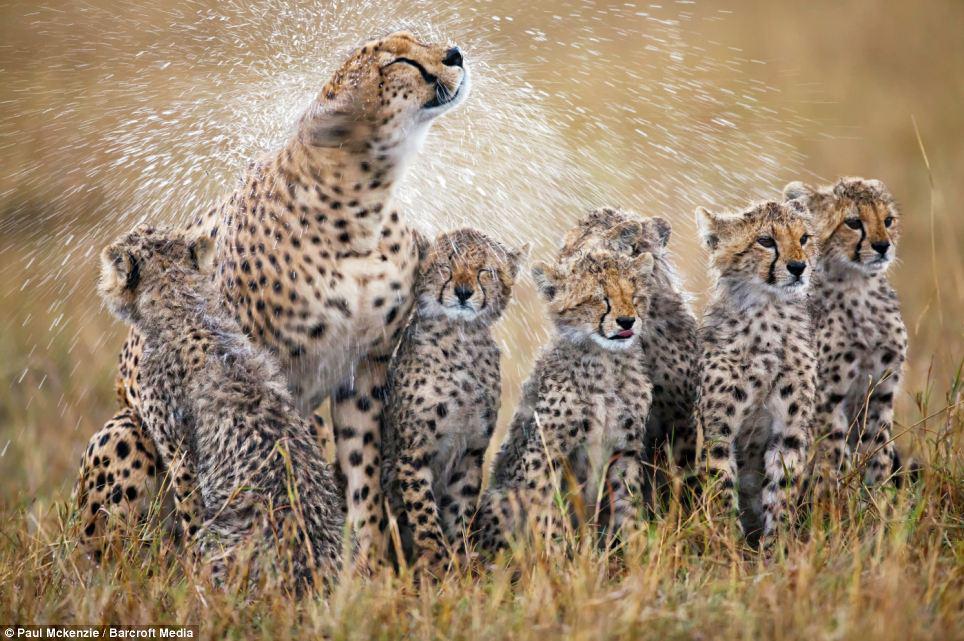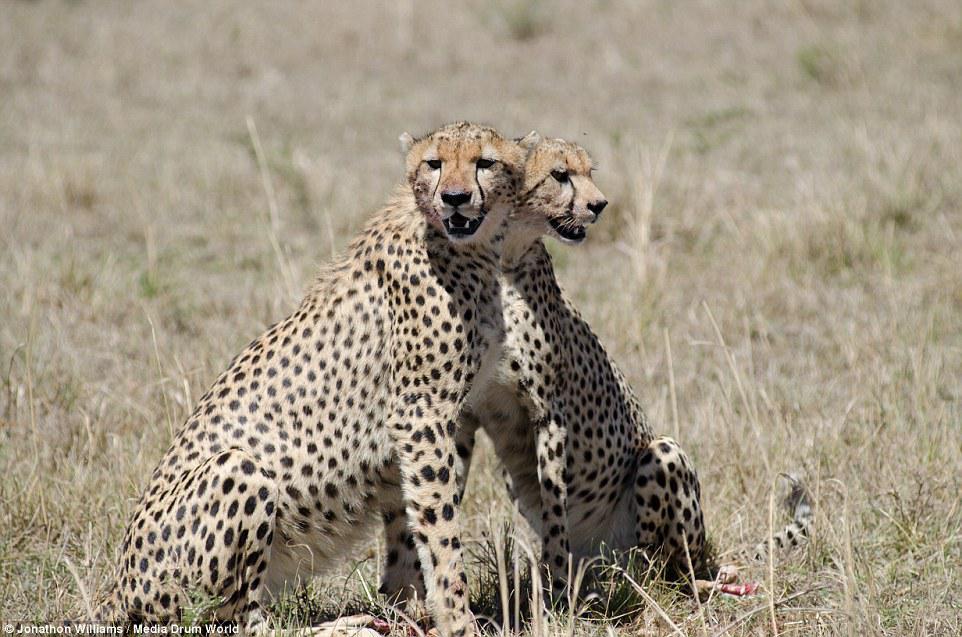The first image is the image on the left, the second image is the image on the right. Assess this claim about the two images: "Each image shows exactly one pair of wild spotted cts with their heads overlapping.". Correct or not? Answer yes or no. No. 